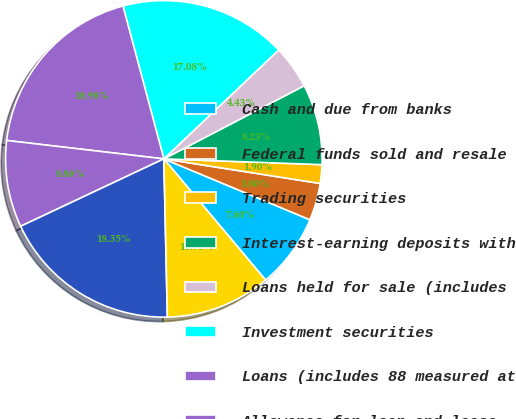<chart> <loc_0><loc_0><loc_500><loc_500><pie_chart><fcel>Cash and due from banks<fcel>Federal funds sold and resale<fcel>Trading securities<fcel>Interest-earning deposits with<fcel>Loans held for sale (includes<fcel>Investment securities<fcel>Loans (includes 88 measured at<fcel>Allowance for loan and lease<fcel>Net loans<fcel>Goodwill<nl><fcel>7.6%<fcel>3.8%<fcel>1.9%<fcel>8.23%<fcel>4.43%<fcel>17.08%<fcel>18.98%<fcel>8.86%<fcel>18.35%<fcel>10.76%<nl></chart> 